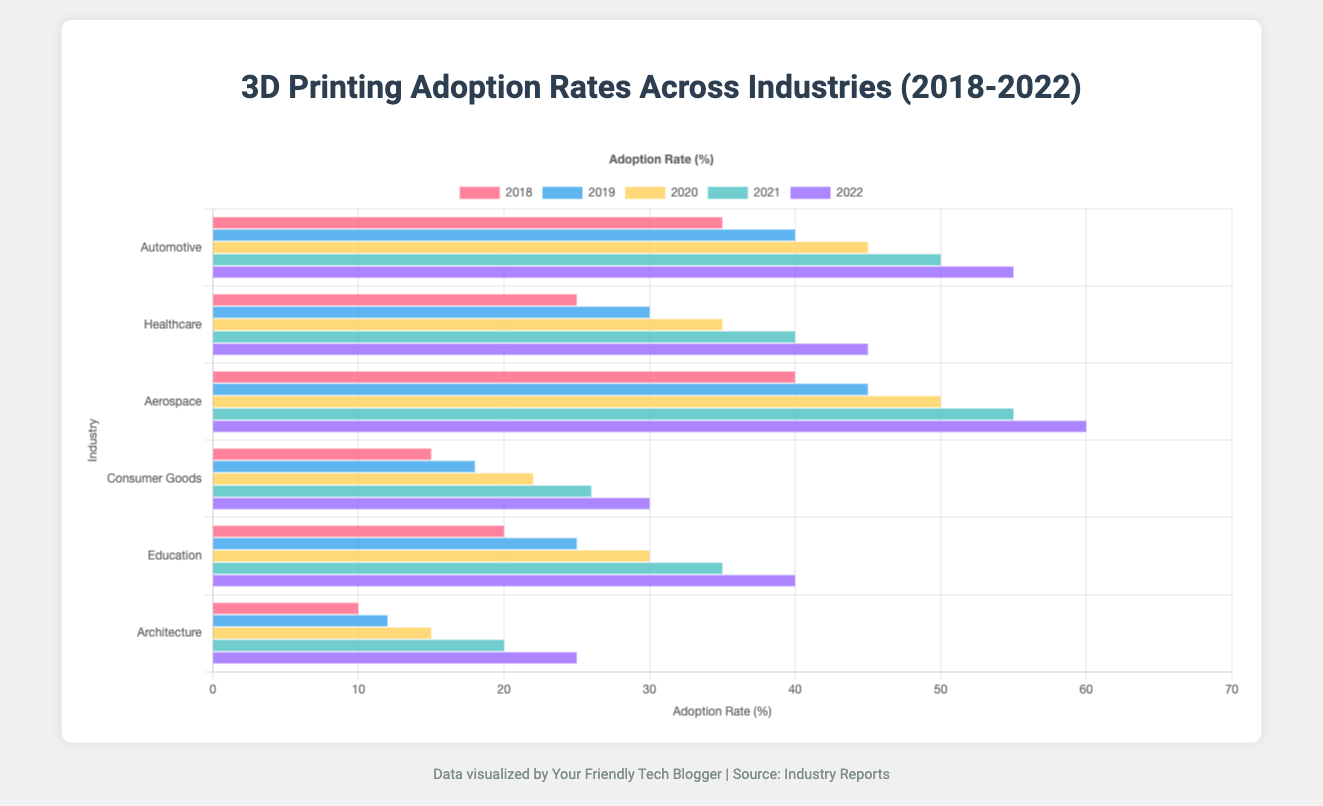What's the industry with the highest adoption rate in 2022? The figure shows the adoption rate for various industries and different years, with Aerospace having the highest bar in the 2022 section.
Answer: Aerospace How much did the adoption rate for Consumer Goods increase from 2018 to 2022? The adoption rate for Consumer Goods was 15% in 2018 and increased to 30% in 2022. The increase is 30 - 15 = 15%.
Answer: 15% Which industry saw an adoption rate increase of 10% each consecutive year from 2018 to 2022? By looking at the bars, the Healthcare industry's bar increments stand out as it increases from 25% (2018), 30% (2019), 35% (2020), 40% (2021), to 45% (2022), reflecting a 10% increment each consecutive year.
Answer: Healthcare Was the adoption rate for Education higher or lower than that for Architecture in 2020? By comparing the heights of the bars for Education and Architecture in 2020, the Education bar is taller (30%) than the Architecture bar (15%).
Answer: Higher What was the average adoption rate for Automotive from 2018 to 2022? To find the average, sum the adoption rates for Automotive over the years: (35 + 40 + 45 + 50 + 55) = 225. Divide by the number of years (5), resulting in an average of 225 / 5 = 45%.
Answer: 45% Which industry had the smallest increase in adoption rate from 2021 to 2022? By observing the changes in bar heights between 2021 and 2022, Architecture has the smallest increase, from 20% to 25%, showing an increase of 5%.
Answer: Architecture Compare the adoption rate of Aerospace in 2019 to that of Automotive in 2020. Which was higher? The Aerospace adoption rate in 2019 is 45%, while the Automotive rate in 2020 is also 45%. Since both are equal, neither is higher.
Answer: Equal How much did the adoption rate in Healthcare differ between 2018 and 2022? The adoption rate in Healthcare was 25% in 2018 and 45% in 2022. The difference is 45 - 25 = 20%.
Answer: 20% Which industry had the consistent increase in adoption rate, showing no years of decline, from 2018 to 2022? Comparing year-over-year changes for the bars, Automative consistently increased from 35% to 55% without decline over the years.
Answer: Automotive 